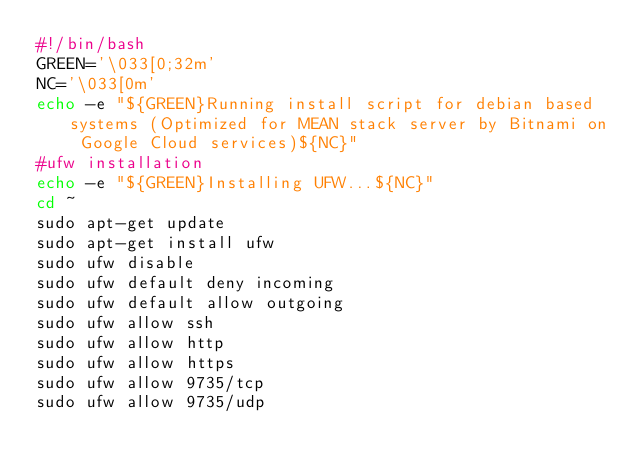<code> <loc_0><loc_0><loc_500><loc_500><_Bash_>#!/bin/bash
GREEN='\033[0;32m'
NC='\033[0m'
echo -e "${GREEN}Running install script for debian based systems (Optimized for MEAN stack server by Bitnami on Google Cloud services)${NC}"
#ufw installation
echo -e "${GREEN}Installing UFW...${NC}"
cd ~
sudo apt-get update
sudo apt-get install ufw
sudo ufw disable
sudo ufw default deny incoming 
sudo ufw default allow outgoing 
sudo ufw allow ssh  
sudo ufw allow http 
sudo ufw allow https 
sudo ufw allow 9735/tcp 
sudo ufw allow 9735/udp </code> 